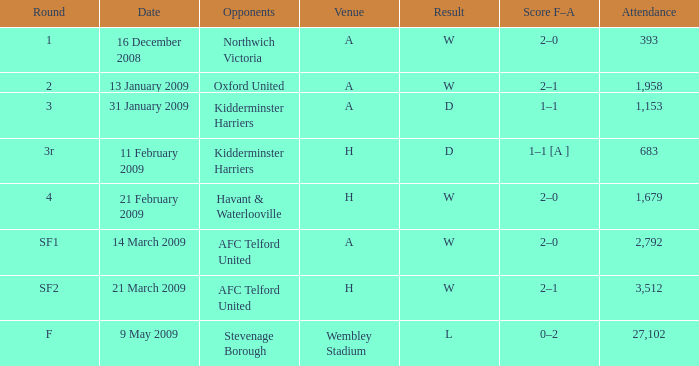What is the circular on 21 february 2009? 4.0. 